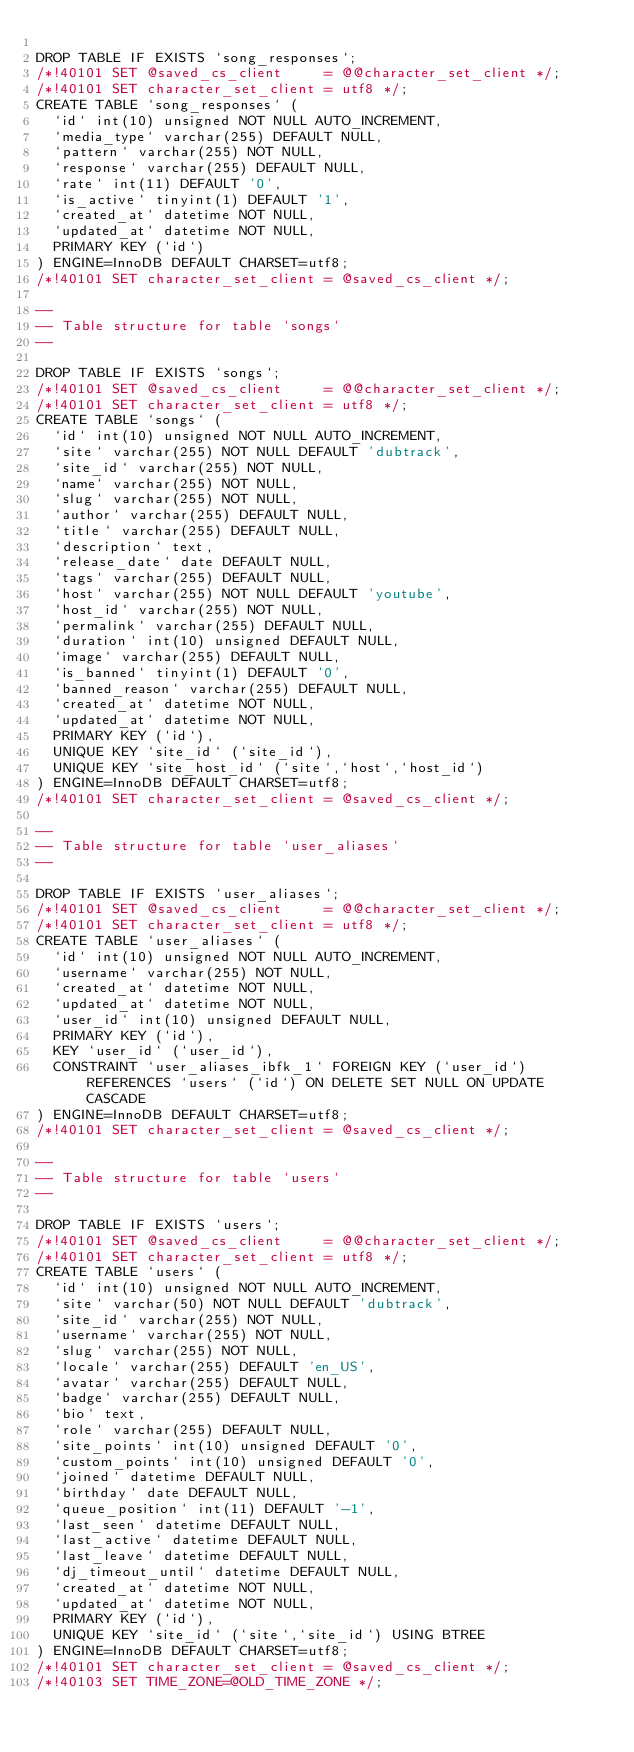<code> <loc_0><loc_0><loc_500><loc_500><_SQL_>
DROP TABLE IF EXISTS `song_responses`;
/*!40101 SET @saved_cs_client     = @@character_set_client */;
/*!40101 SET character_set_client = utf8 */;
CREATE TABLE `song_responses` (
  `id` int(10) unsigned NOT NULL AUTO_INCREMENT,
  `media_type` varchar(255) DEFAULT NULL,
  `pattern` varchar(255) NOT NULL,
  `response` varchar(255) DEFAULT NULL,
  `rate` int(11) DEFAULT '0',
  `is_active` tinyint(1) DEFAULT '1',
  `created_at` datetime NOT NULL,
  `updated_at` datetime NOT NULL,
  PRIMARY KEY (`id`)
) ENGINE=InnoDB DEFAULT CHARSET=utf8;
/*!40101 SET character_set_client = @saved_cs_client */;

--
-- Table structure for table `songs`
--

DROP TABLE IF EXISTS `songs`;
/*!40101 SET @saved_cs_client     = @@character_set_client */;
/*!40101 SET character_set_client = utf8 */;
CREATE TABLE `songs` (
  `id` int(10) unsigned NOT NULL AUTO_INCREMENT,
  `site` varchar(255) NOT NULL DEFAULT 'dubtrack',
  `site_id` varchar(255) NOT NULL,
  `name` varchar(255) NOT NULL,
  `slug` varchar(255) NOT NULL,
  `author` varchar(255) DEFAULT NULL,
  `title` varchar(255) DEFAULT NULL,
  `description` text,
  `release_date` date DEFAULT NULL,
  `tags` varchar(255) DEFAULT NULL,
  `host` varchar(255) NOT NULL DEFAULT 'youtube',
  `host_id` varchar(255) NOT NULL,
  `permalink` varchar(255) DEFAULT NULL,
  `duration` int(10) unsigned DEFAULT NULL,
  `image` varchar(255) DEFAULT NULL,
  `is_banned` tinyint(1) DEFAULT '0',
  `banned_reason` varchar(255) DEFAULT NULL,
  `created_at` datetime NOT NULL,
  `updated_at` datetime NOT NULL,
  PRIMARY KEY (`id`),
  UNIQUE KEY `site_id` (`site_id`),
  UNIQUE KEY `site_host_id` (`site`,`host`,`host_id`)
) ENGINE=InnoDB DEFAULT CHARSET=utf8;
/*!40101 SET character_set_client = @saved_cs_client */;

--
-- Table structure for table `user_aliases`
--

DROP TABLE IF EXISTS `user_aliases`;
/*!40101 SET @saved_cs_client     = @@character_set_client */;
/*!40101 SET character_set_client = utf8 */;
CREATE TABLE `user_aliases` (
  `id` int(10) unsigned NOT NULL AUTO_INCREMENT,
  `username` varchar(255) NOT NULL,
  `created_at` datetime NOT NULL,
  `updated_at` datetime NOT NULL,
  `user_id` int(10) unsigned DEFAULT NULL,
  PRIMARY KEY (`id`),
  KEY `user_id` (`user_id`),
  CONSTRAINT `user_aliases_ibfk_1` FOREIGN KEY (`user_id`) REFERENCES `users` (`id`) ON DELETE SET NULL ON UPDATE CASCADE
) ENGINE=InnoDB DEFAULT CHARSET=utf8;
/*!40101 SET character_set_client = @saved_cs_client */;

--
-- Table structure for table `users`
--

DROP TABLE IF EXISTS `users`;
/*!40101 SET @saved_cs_client     = @@character_set_client */;
/*!40101 SET character_set_client = utf8 */;
CREATE TABLE `users` (
  `id` int(10) unsigned NOT NULL AUTO_INCREMENT,
  `site` varchar(50) NOT NULL DEFAULT 'dubtrack',
  `site_id` varchar(255) NOT NULL,
  `username` varchar(255) NOT NULL,
  `slug` varchar(255) NOT NULL,
  `locale` varchar(255) DEFAULT 'en_US',
  `avatar` varchar(255) DEFAULT NULL,
  `badge` varchar(255) DEFAULT NULL,
  `bio` text,
  `role` varchar(255) DEFAULT NULL,
  `site_points` int(10) unsigned DEFAULT '0',
  `custom_points` int(10) unsigned DEFAULT '0',
  `joined` datetime DEFAULT NULL,
  `birthday` date DEFAULT NULL,
  `queue_position` int(11) DEFAULT '-1',
  `last_seen` datetime DEFAULT NULL,
  `last_active` datetime DEFAULT NULL,
  `last_leave` datetime DEFAULT NULL,
  `dj_timeout_until` datetime DEFAULT NULL,
  `created_at` datetime NOT NULL,
  `updated_at` datetime NOT NULL,
  PRIMARY KEY (`id`),
  UNIQUE KEY `site_id` (`site`,`site_id`) USING BTREE
) ENGINE=InnoDB DEFAULT CHARSET=utf8;
/*!40101 SET character_set_client = @saved_cs_client */;
/*!40103 SET TIME_ZONE=@OLD_TIME_ZONE */;
</code> 